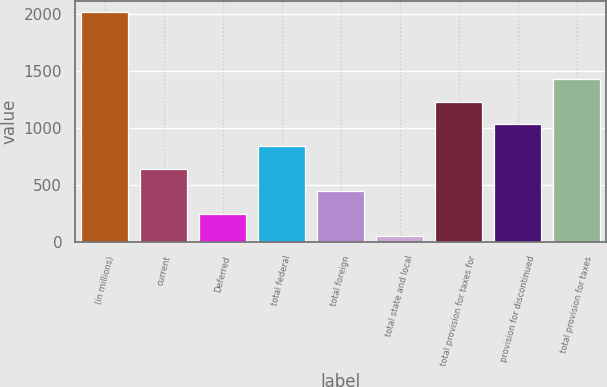Convert chart. <chart><loc_0><loc_0><loc_500><loc_500><bar_chart><fcel>(in millions)<fcel>current<fcel>Deferred<fcel>total federal<fcel>total foreign<fcel>total state and local<fcel>total provision for taxes for<fcel>provision for discontinued<fcel>total provision for taxes<nl><fcel>2013<fcel>638.9<fcel>246.3<fcel>835.2<fcel>442.6<fcel>50<fcel>1227.8<fcel>1031.5<fcel>1424.1<nl></chart> 